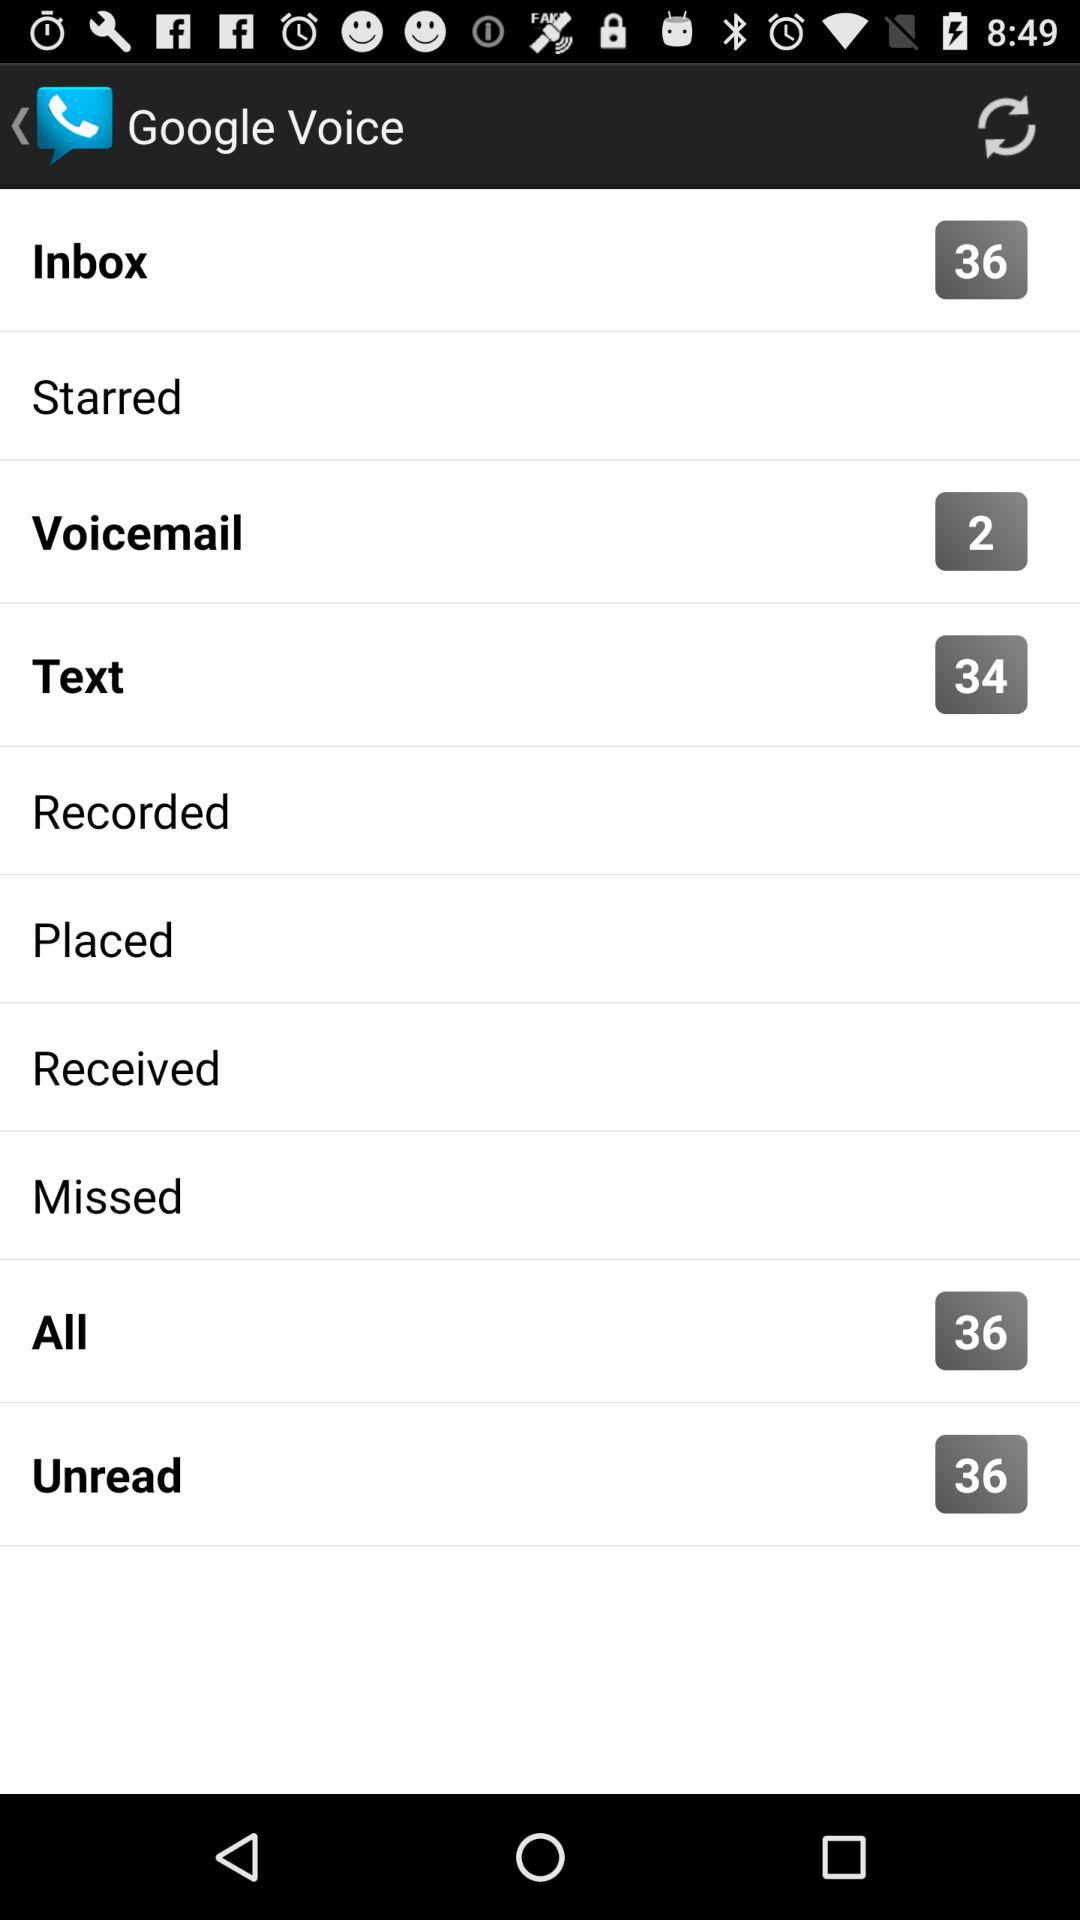How many messages are there in "All"? There are 36 messages in "All". 